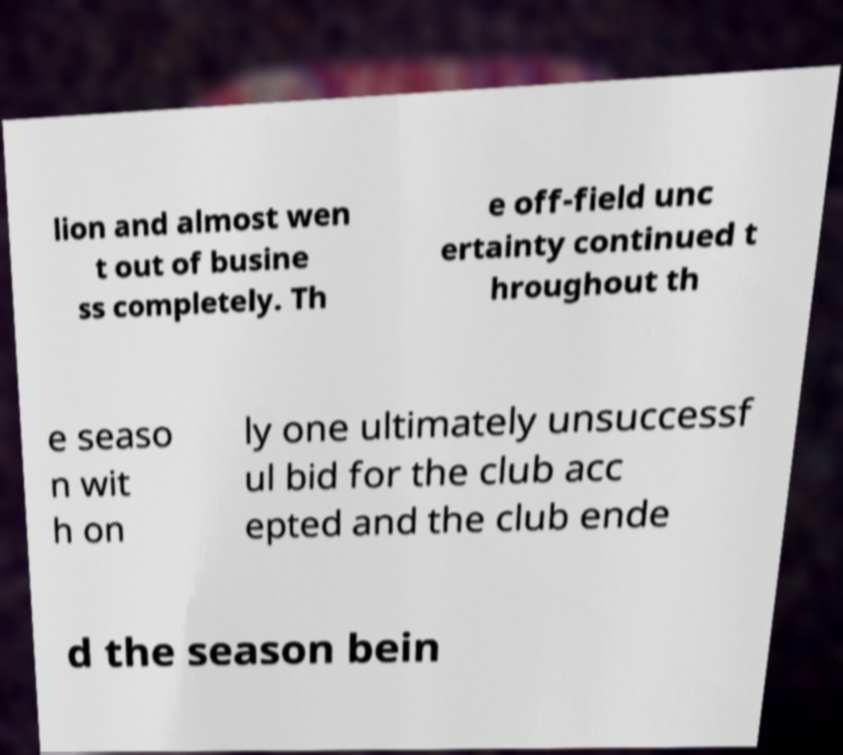Please read and relay the text visible in this image. What does it say? lion and almost wen t out of busine ss completely. Th e off-field unc ertainty continued t hroughout th e seaso n wit h on ly one ultimately unsuccessf ul bid for the club acc epted and the club ende d the season bein 